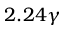<formula> <loc_0><loc_0><loc_500><loc_500>2 . 2 4 \gamma</formula> 